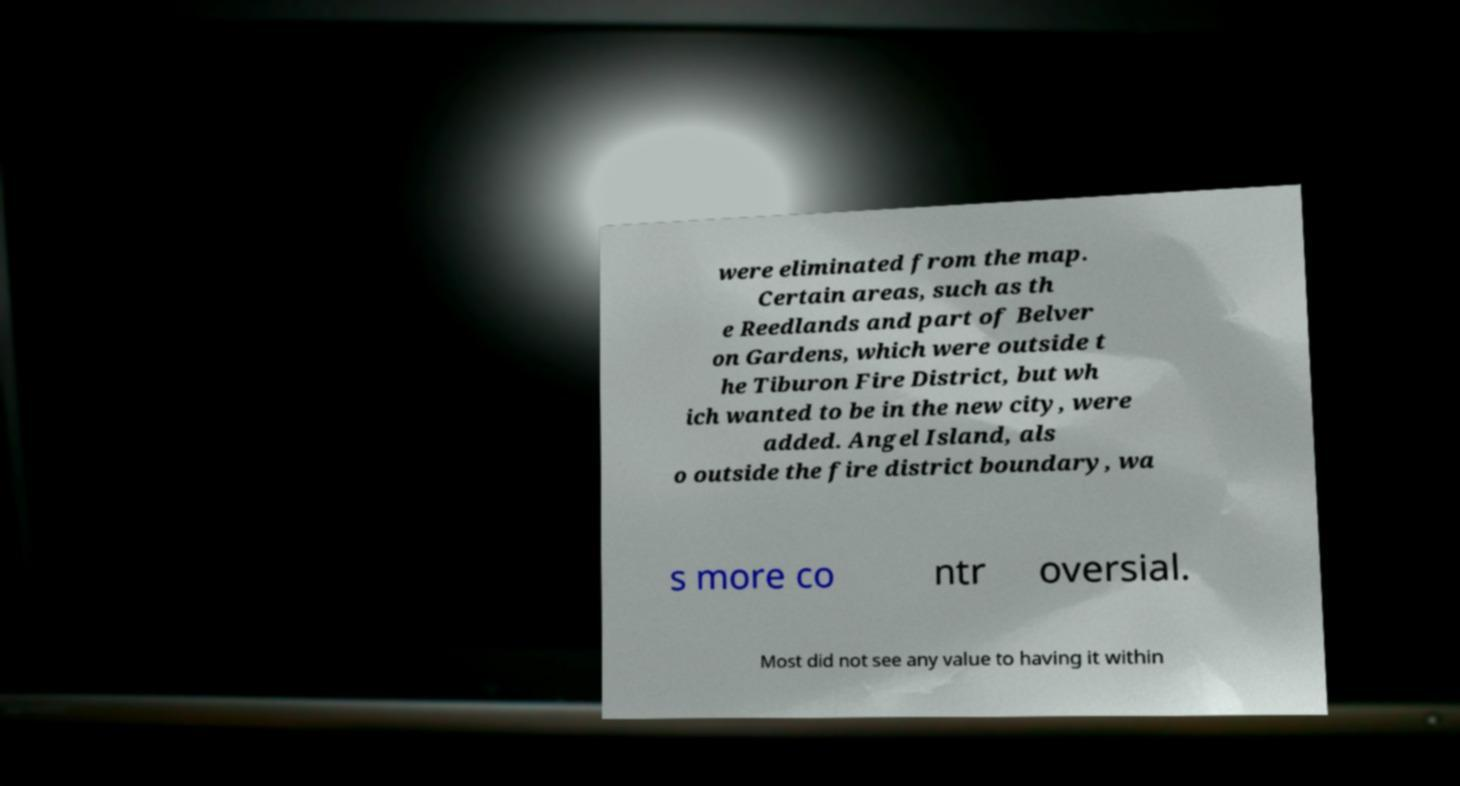Please identify and transcribe the text found in this image. were eliminated from the map. Certain areas, such as th e Reedlands and part of Belver on Gardens, which were outside t he Tiburon Fire District, but wh ich wanted to be in the new city, were added. Angel Island, als o outside the fire district boundary, wa s more co ntr oversial. Most did not see any value to having it within 